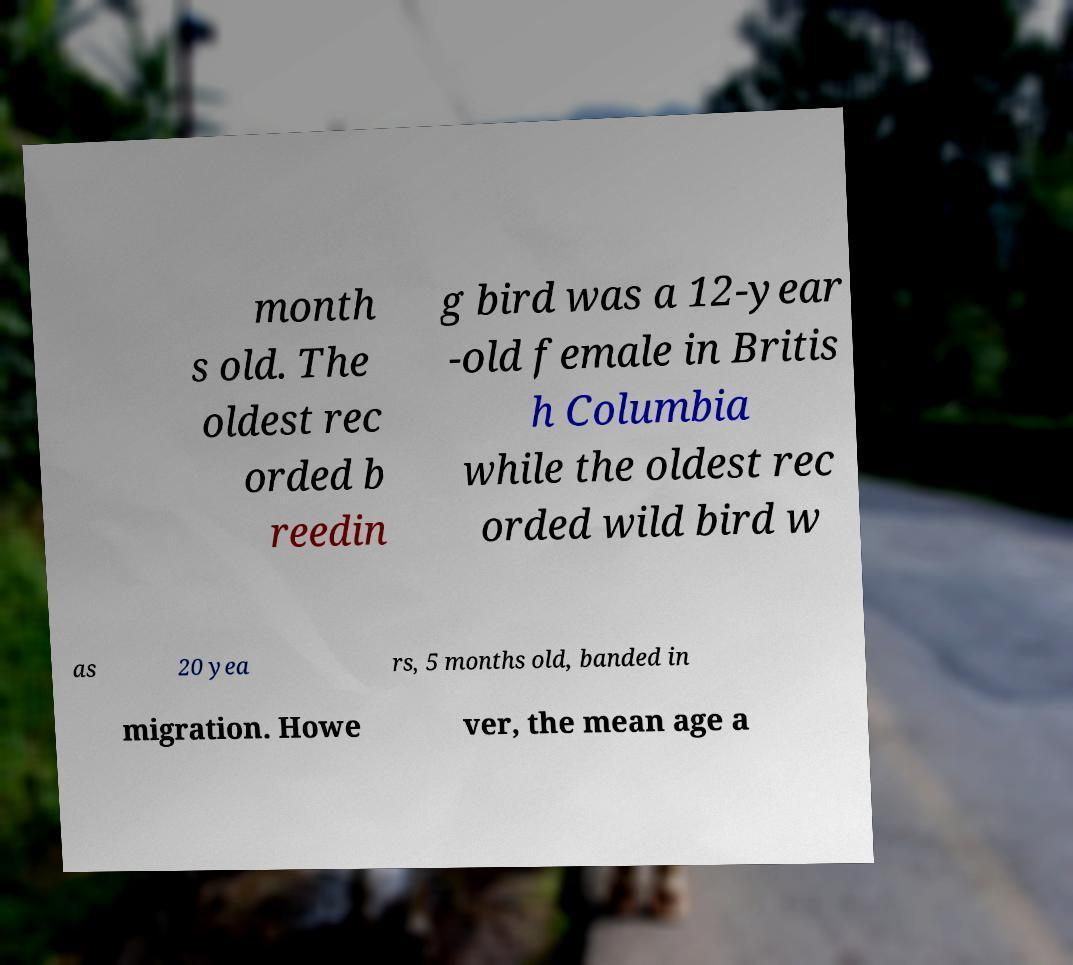I need the written content from this picture converted into text. Can you do that? month s old. The oldest rec orded b reedin g bird was a 12-year -old female in Britis h Columbia while the oldest rec orded wild bird w as 20 yea rs, 5 months old, banded in migration. Howe ver, the mean age a 